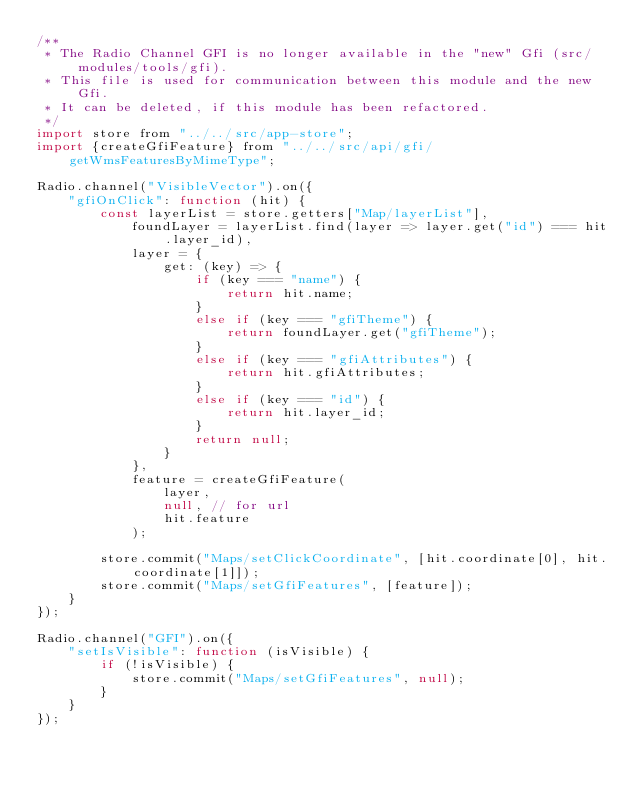Convert code to text. <code><loc_0><loc_0><loc_500><loc_500><_JavaScript_>/**
 * The Radio Channel GFI is no longer available in the "new" Gfi (src/modules/tools/gfi).
 * This file is used for communication between this module and the new Gfi.
 * It can be deleted, if this module has been refactored.
 */
import store from "../../src/app-store";
import {createGfiFeature} from "../../src/api/gfi/getWmsFeaturesByMimeType";

Radio.channel("VisibleVector").on({
    "gfiOnClick": function (hit) {
        const layerList = store.getters["Map/layerList"],
            foundLayer = layerList.find(layer => layer.get("id") === hit.layer_id),
            layer = {
                get: (key) => {
                    if (key === "name") {
                        return hit.name;
                    }
                    else if (key === "gfiTheme") {
                        return foundLayer.get("gfiTheme");
                    }
                    else if (key === "gfiAttributes") {
                        return hit.gfiAttributes;
                    }
                    else if (key === "id") {
                        return hit.layer_id;
                    }
                    return null;
                }
            },
            feature = createGfiFeature(
                layer,
                null, // for url
                hit.feature
            );

        store.commit("Maps/setClickCoordinate", [hit.coordinate[0], hit.coordinate[1]]);
        store.commit("Maps/setGfiFeatures", [feature]);
    }
});

Radio.channel("GFI").on({
    "setIsVisible": function (isVisible) {
        if (!isVisible) {
            store.commit("Maps/setGfiFeatures", null);
        }
    }
});
</code> 